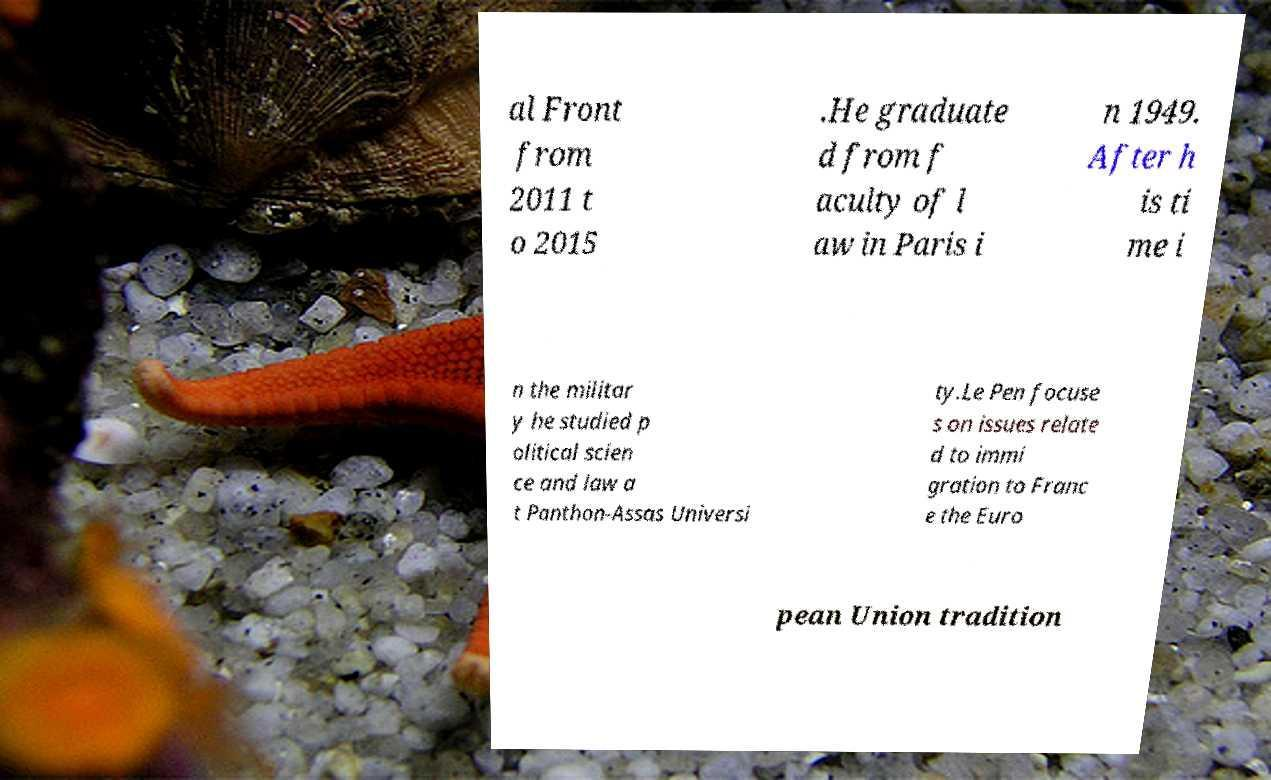I need the written content from this picture converted into text. Can you do that? al Front from 2011 t o 2015 .He graduate d from f aculty of l aw in Paris i n 1949. After h is ti me i n the militar y he studied p olitical scien ce and law a t Panthon-Assas Universi ty.Le Pen focuse s on issues relate d to immi gration to Franc e the Euro pean Union tradition 